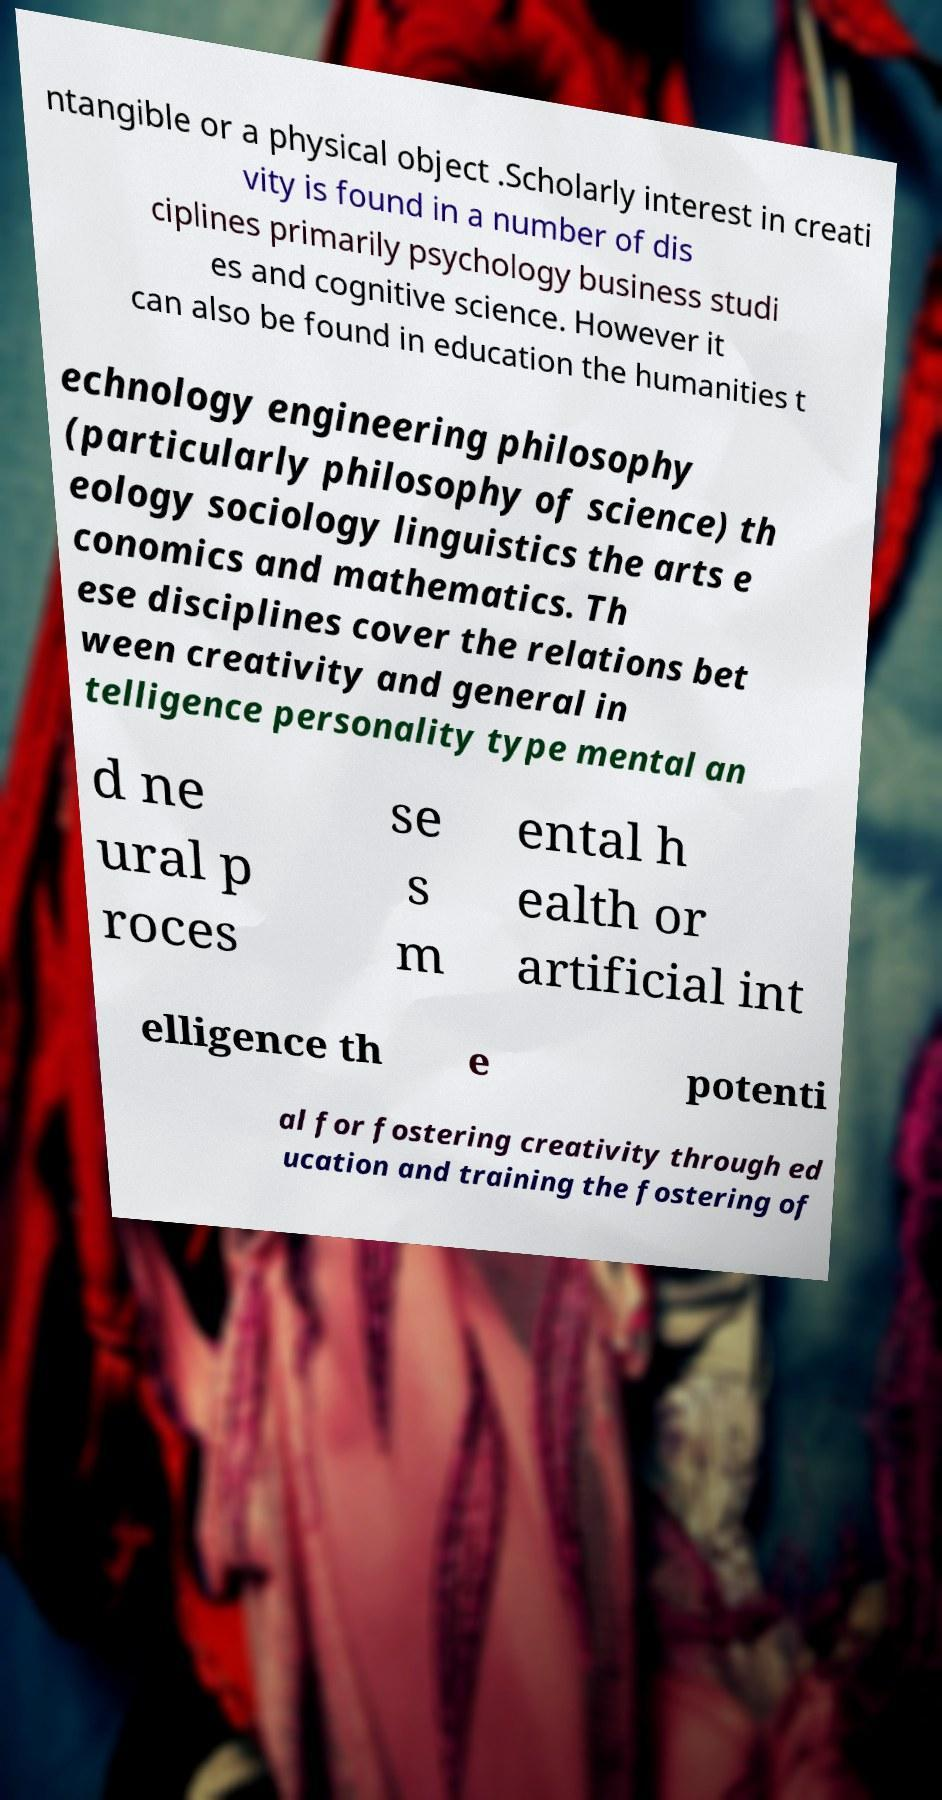There's text embedded in this image that I need extracted. Can you transcribe it verbatim? ntangible or a physical object .Scholarly interest in creati vity is found in a number of dis ciplines primarily psychology business studi es and cognitive science. However it can also be found in education the humanities t echnology engineering philosophy (particularly philosophy of science) th eology sociology linguistics the arts e conomics and mathematics. Th ese disciplines cover the relations bet ween creativity and general in telligence personality type mental an d ne ural p roces se s m ental h ealth or artificial int elligence th e potenti al for fostering creativity through ed ucation and training the fostering of 